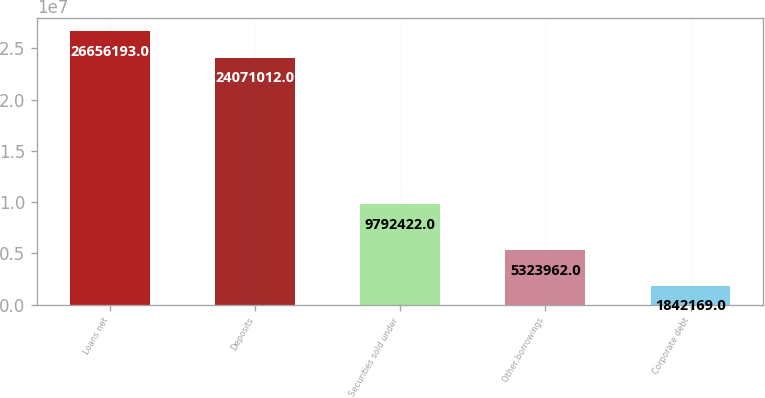<chart> <loc_0><loc_0><loc_500><loc_500><bar_chart><fcel>Loans net<fcel>Deposits<fcel>Securities sold under<fcel>Other borrowings<fcel>Corporate debt<nl><fcel>2.66562e+07<fcel>2.4071e+07<fcel>9.79242e+06<fcel>5.32396e+06<fcel>1.84217e+06<nl></chart> 